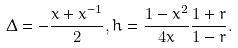Convert formula to latex. <formula><loc_0><loc_0><loc_500><loc_500>\Delta = - \frac { x + x ^ { - 1 } } { 2 } , h = \frac { 1 - x ^ { 2 } } { 4 x } \frac { 1 + r } { 1 - r } .</formula> 